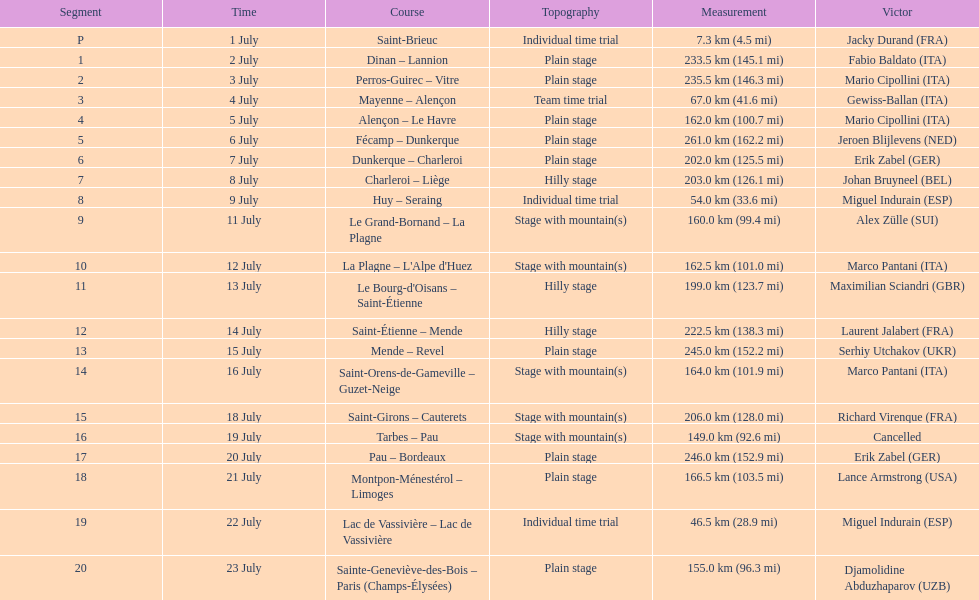How many stages were at least 200 km in length in the 1995 tour de france? 9. 